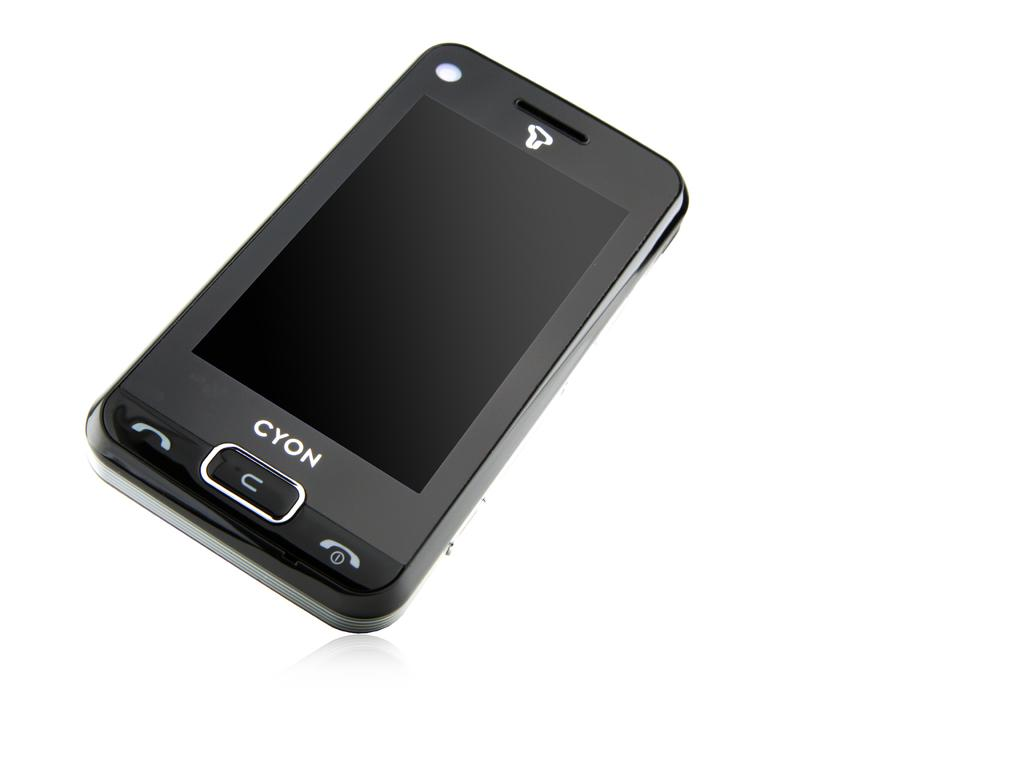<image>
Write a terse but informative summary of the picture. A black Cyon phone is laying against a white background. 